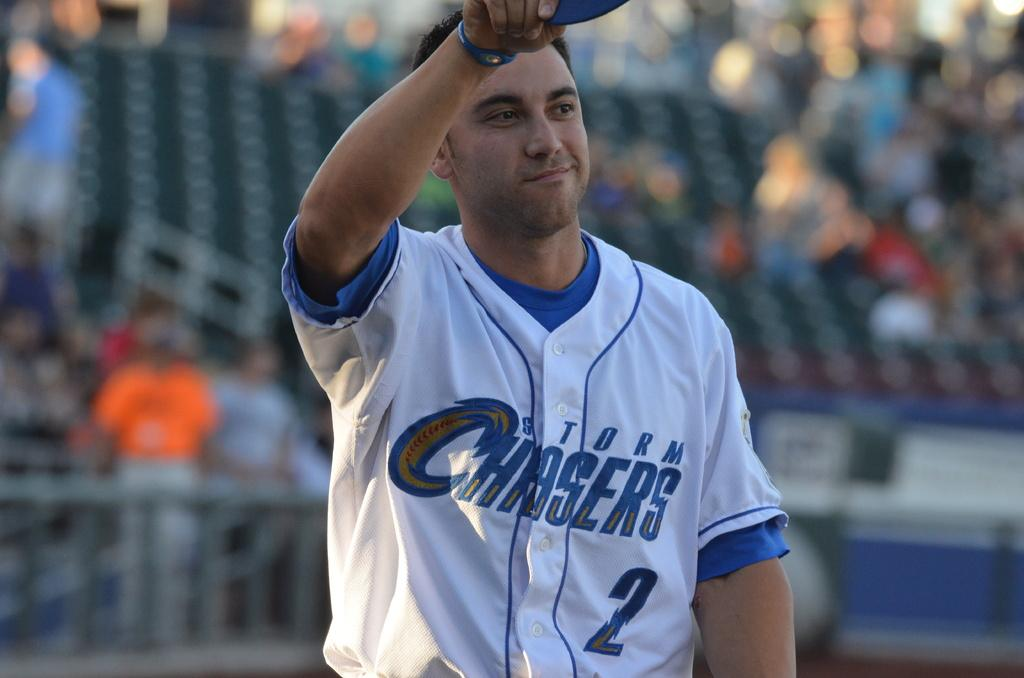Provide a one-sentence caption for the provided image. Baseball player for the Chaser team is out on the field. 